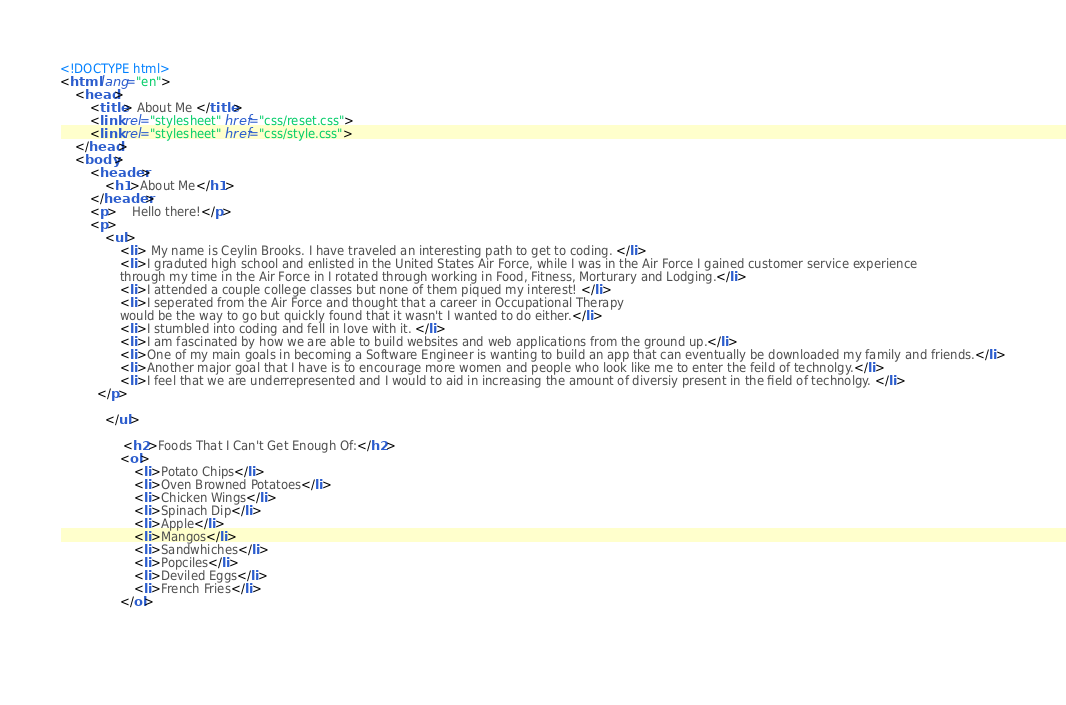<code> <loc_0><loc_0><loc_500><loc_500><_HTML_><!DOCTYPE html>
<html lang="en">
    <head>
        <title> About Me </title>
        <link rel="stylesheet" href="css/reset.css">
        <link rel="stylesheet" href="css/style.css">
    </head>
    <body>
        <header>
            <h1>About Me</h1>
        </header>
        <p>    Hello there!</p>
        <p>
            <ul>
                <li> My name is Ceylin Brooks. I have traveled an interesting path to get to coding. </li>
                <li>I graduted high school and enlisted in the United States Air Force, while I was in the Air Force I gained customer service experience 
                through my time in the Air Force in I rotated through working in Food, Fitness, Morturary and Lodging.</li>
                <li>I attended a couple college classes but none of them piqued my interest! </li>
                <li>I seperated from the Air Force and thought that a career in Occupational Therapy
                would be the way to go but quickly found that it wasn't I wanted to do either.</li>
                <li>I stumbled into coding and fell in love with it. </li>
                <li>I am fascinated by how we are able to build websites and web applications from the ground up.</li>
                <li>One of my main goals in becoming a Software Engineer is wanting to build an app that can eventually be downloaded my family and friends.</li>
                <li>Another major goal that I have is to encourage more women and people who look like me to enter the feild of technolgy.</li>
                <li>I feel that we are underrepresented and I would to aid in increasing the amount of diversiy present in the field of technolgy. </li> 
          </p>
             
            </ul>
            
                 <h2>Foods That I Can't Get Enough Of:</h2> 
                <ol>
                    <li>Potato Chips</li>
                    <li>Oven Browned Potatoes</li>
                    <li>Chicken Wings</li>
                    <li>Spinach Dip</li>
                    <li>Apple</li>
                    <li>Mangos</li>
                    <li>Sandwhiches</li>
                    <li>Popciles</li>
                    <li>Deviled Eggs</li>
                    <li>French Fries</li>
                </ol>
                

            </code> 